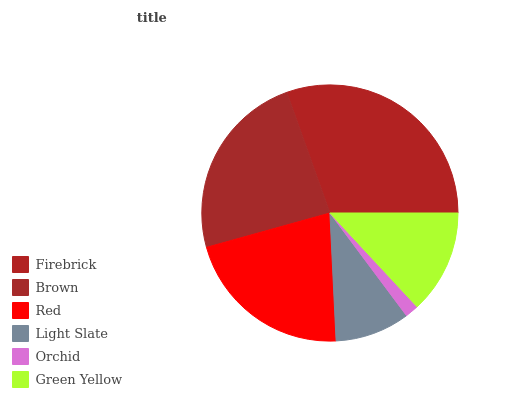Is Orchid the minimum?
Answer yes or no. Yes. Is Firebrick the maximum?
Answer yes or no. Yes. Is Brown the minimum?
Answer yes or no. No. Is Brown the maximum?
Answer yes or no. No. Is Firebrick greater than Brown?
Answer yes or no. Yes. Is Brown less than Firebrick?
Answer yes or no. Yes. Is Brown greater than Firebrick?
Answer yes or no. No. Is Firebrick less than Brown?
Answer yes or no. No. Is Red the high median?
Answer yes or no. Yes. Is Green Yellow the low median?
Answer yes or no. Yes. Is Orchid the high median?
Answer yes or no. No. Is Red the low median?
Answer yes or no. No. 